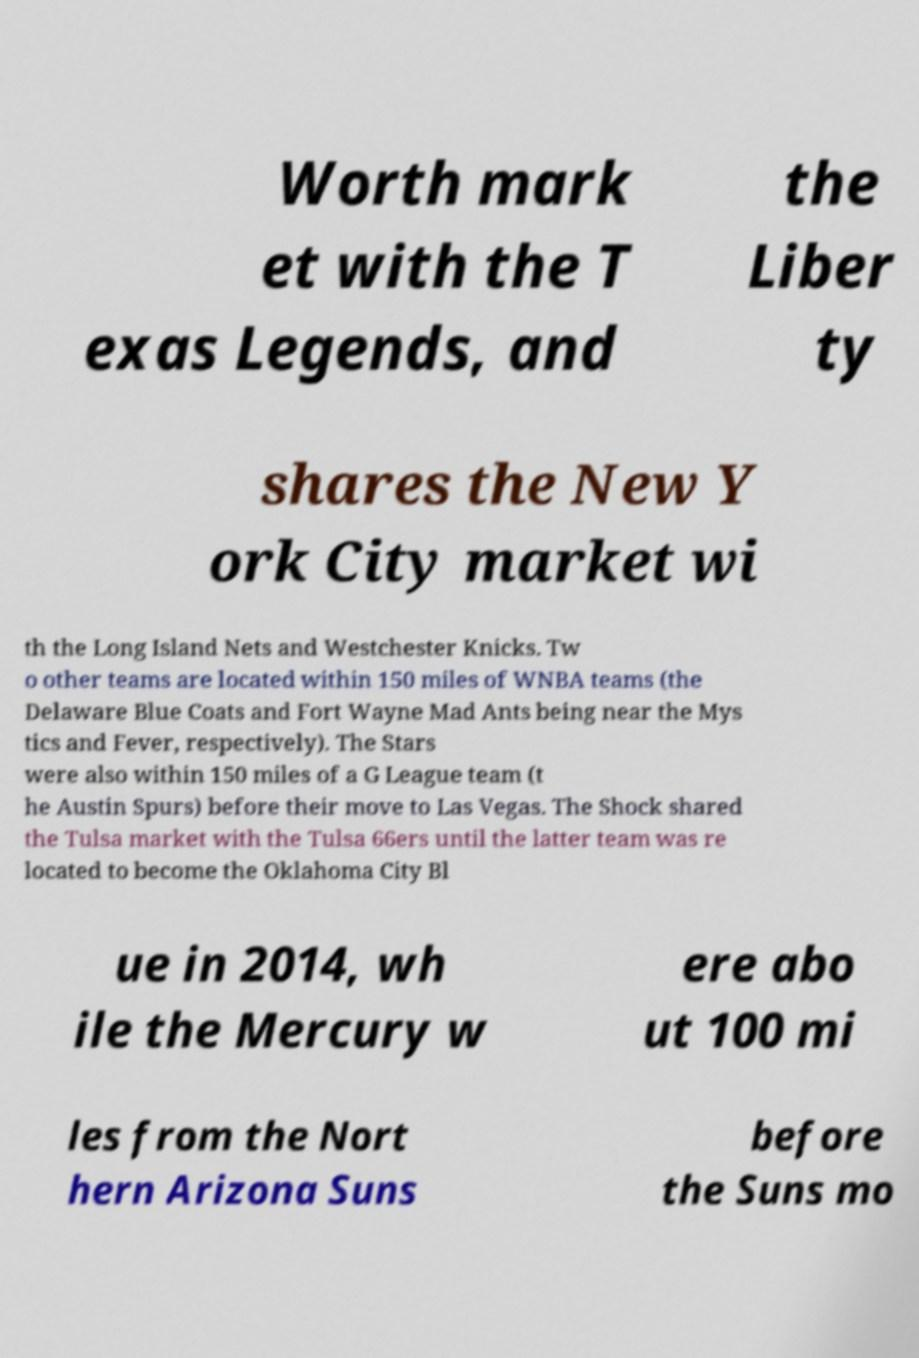I need the written content from this picture converted into text. Can you do that? Worth mark et with the T exas Legends, and the Liber ty shares the New Y ork City market wi th the Long Island Nets and Westchester Knicks. Tw o other teams are located within 150 miles of WNBA teams (the Delaware Blue Coats and Fort Wayne Mad Ants being near the Mys tics and Fever, respectively). The Stars were also within 150 miles of a G League team (t he Austin Spurs) before their move to Las Vegas. The Shock shared the Tulsa market with the Tulsa 66ers until the latter team was re located to become the Oklahoma City Bl ue in 2014, wh ile the Mercury w ere abo ut 100 mi les from the Nort hern Arizona Suns before the Suns mo 